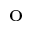Convert formula to latex. <formula><loc_0><loc_0><loc_500><loc_500>^ { o }</formula> 